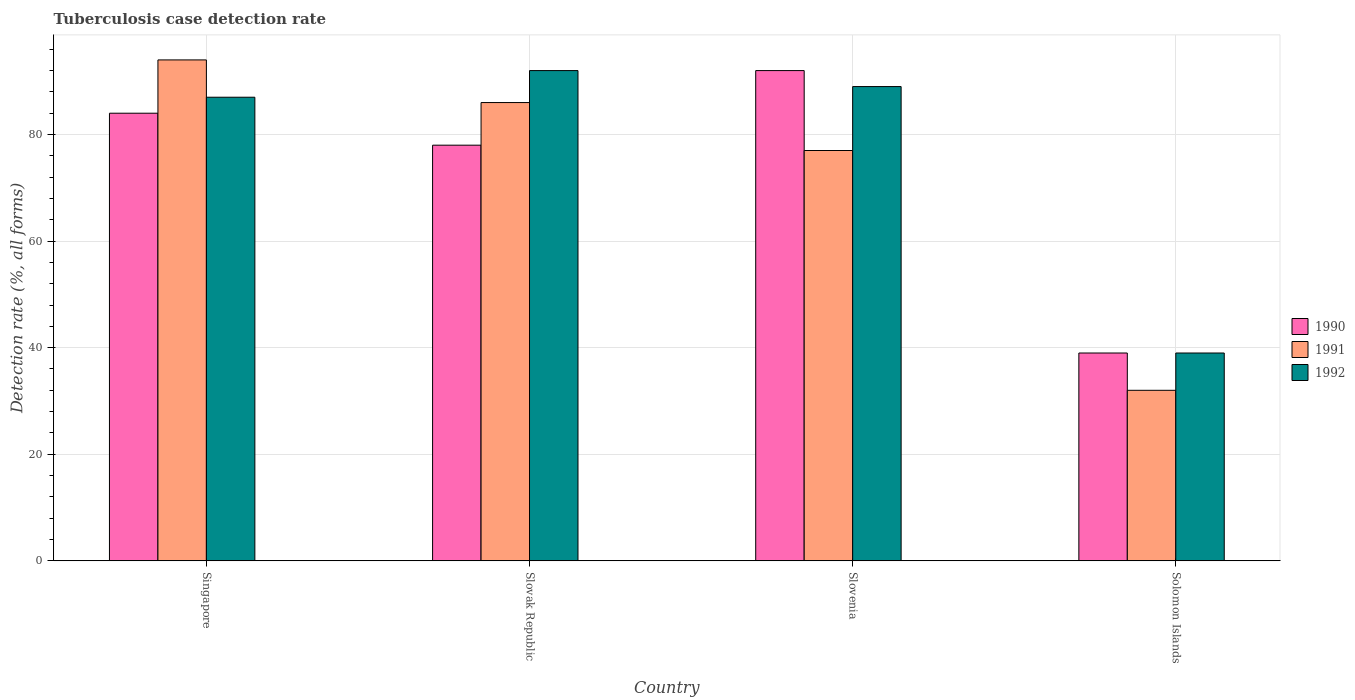How many different coloured bars are there?
Provide a succinct answer. 3. How many bars are there on the 1st tick from the left?
Your response must be concise. 3. What is the label of the 2nd group of bars from the left?
Provide a succinct answer. Slovak Republic. In how many cases, is the number of bars for a given country not equal to the number of legend labels?
Ensure brevity in your answer.  0. What is the tuberculosis case detection rate in in 1990 in Solomon Islands?
Your response must be concise. 39. Across all countries, what is the maximum tuberculosis case detection rate in in 1992?
Provide a succinct answer. 92. In which country was the tuberculosis case detection rate in in 1991 maximum?
Offer a very short reply. Singapore. In which country was the tuberculosis case detection rate in in 1991 minimum?
Your response must be concise. Solomon Islands. What is the total tuberculosis case detection rate in in 1992 in the graph?
Provide a short and direct response. 307. What is the difference between the tuberculosis case detection rate in in 1991 in Singapore and that in Slovenia?
Ensure brevity in your answer.  17. What is the difference between the tuberculosis case detection rate in in 1992 in Solomon Islands and the tuberculosis case detection rate in in 1990 in Singapore?
Your answer should be very brief. -45. What is the average tuberculosis case detection rate in in 1992 per country?
Ensure brevity in your answer.  76.75. In how many countries, is the tuberculosis case detection rate in in 1992 greater than 24 %?
Offer a very short reply. 4. What is the ratio of the tuberculosis case detection rate in in 1990 in Slovenia to that in Solomon Islands?
Provide a succinct answer. 2.36. Is the difference between the tuberculosis case detection rate in in 1990 in Singapore and Solomon Islands greater than the difference between the tuberculosis case detection rate in in 1991 in Singapore and Solomon Islands?
Offer a very short reply. No. What is the difference between the highest and the lowest tuberculosis case detection rate in in 1990?
Provide a succinct answer. 53. What does the 2nd bar from the right in Solomon Islands represents?
Keep it short and to the point. 1991. What is the difference between two consecutive major ticks on the Y-axis?
Make the answer very short. 20. Does the graph contain any zero values?
Keep it short and to the point. No. Does the graph contain grids?
Offer a terse response. Yes. What is the title of the graph?
Your answer should be very brief. Tuberculosis case detection rate. What is the label or title of the Y-axis?
Offer a terse response. Detection rate (%, all forms). What is the Detection rate (%, all forms) of 1990 in Singapore?
Your answer should be very brief. 84. What is the Detection rate (%, all forms) in 1991 in Singapore?
Make the answer very short. 94. What is the Detection rate (%, all forms) of 1990 in Slovak Republic?
Keep it short and to the point. 78. What is the Detection rate (%, all forms) in 1991 in Slovak Republic?
Provide a succinct answer. 86. What is the Detection rate (%, all forms) of 1992 in Slovak Republic?
Your answer should be compact. 92. What is the Detection rate (%, all forms) of 1990 in Slovenia?
Your answer should be compact. 92. What is the Detection rate (%, all forms) in 1992 in Slovenia?
Provide a short and direct response. 89. What is the Detection rate (%, all forms) of 1991 in Solomon Islands?
Make the answer very short. 32. What is the Detection rate (%, all forms) in 1992 in Solomon Islands?
Keep it short and to the point. 39. Across all countries, what is the maximum Detection rate (%, all forms) in 1990?
Ensure brevity in your answer.  92. Across all countries, what is the maximum Detection rate (%, all forms) in 1991?
Provide a succinct answer. 94. Across all countries, what is the maximum Detection rate (%, all forms) in 1992?
Your answer should be compact. 92. Across all countries, what is the minimum Detection rate (%, all forms) in 1990?
Ensure brevity in your answer.  39. Across all countries, what is the minimum Detection rate (%, all forms) in 1991?
Ensure brevity in your answer.  32. What is the total Detection rate (%, all forms) of 1990 in the graph?
Make the answer very short. 293. What is the total Detection rate (%, all forms) in 1991 in the graph?
Give a very brief answer. 289. What is the total Detection rate (%, all forms) in 1992 in the graph?
Provide a short and direct response. 307. What is the difference between the Detection rate (%, all forms) in 1990 in Singapore and that in Slovak Republic?
Provide a succinct answer. 6. What is the difference between the Detection rate (%, all forms) in 1991 in Singapore and that in Slovak Republic?
Ensure brevity in your answer.  8. What is the difference between the Detection rate (%, all forms) of 1990 in Singapore and that in Slovenia?
Offer a terse response. -8. What is the difference between the Detection rate (%, all forms) in 1991 in Singapore and that in Slovenia?
Your response must be concise. 17. What is the difference between the Detection rate (%, all forms) in 1992 in Singapore and that in Slovenia?
Give a very brief answer. -2. What is the difference between the Detection rate (%, all forms) of 1990 in Singapore and that in Solomon Islands?
Your response must be concise. 45. What is the difference between the Detection rate (%, all forms) in 1992 in Singapore and that in Solomon Islands?
Ensure brevity in your answer.  48. What is the difference between the Detection rate (%, all forms) of 1990 in Slovak Republic and that in Slovenia?
Offer a very short reply. -14. What is the difference between the Detection rate (%, all forms) of 1992 in Slovak Republic and that in Slovenia?
Your answer should be very brief. 3. What is the difference between the Detection rate (%, all forms) of 1991 in Slovak Republic and that in Solomon Islands?
Offer a very short reply. 54. What is the difference between the Detection rate (%, all forms) in 1992 in Slovak Republic and that in Solomon Islands?
Your response must be concise. 53. What is the difference between the Detection rate (%, all forms) of 1990 in Slovenia and that in Solomon Islands?
Offer a terse response. 53. What is the difference between the Detection rate (%, all forms) of 1991 in Slovenia and that in Solomon Islands?
Your answer should be very brief. 45. What is the difference between the Detection rate (%, all forms) in 1990 in Singapore and the Detection rate (%, all forms) in 1991 in Slovak Republic?
Provide a succinct answer. -2. What is the difference between the Detection rate (%, all forms) in 1990 in Singapore and the Detection rate (%, all forms) in 1992 in Slovak Republic?
Your answer should be compact. -8. What is the difference between the Detection rate (%, all forms) in 1990 in Singapore and the Detection rate (%, all forms) in 1992 in Slovenia?
Provide a short and direct response. -5. What is the difference between the Detection rate (%, all forms) of 1991 in Singapore and the Detection rate (%, all forms) of 1992 in Slovenia?
Your answer should be very brief. 5. What is the difference between the Detection rate (%, all forms) in 1990 in Singapore and the Detection rate (%, all forms) in 1991 in Solomon Islands?
Your answer should be very brief. 52. What is the difference between the Detection rate (%, all forms) of 1990 in Singapore and the Detection rate (%, all forms) of 1992 in Solomon Islands?
Make the answer very short. 45. What is the difference between the Detection rate (%, all forms) of 1990 in Slovak Republic and the Detection rate (%, all forms) of 1991 in Slovenia?
Offer a terse response. 1. What is the difference between the Detection rate (%, all forms) in 1990 in Slovak Republic and the Detection rate (%, all forms) in 1992 in Slovenia?
Offer a very short reply. -11. What is the difference between the Detection rate (%, all forms) of 1991 in Slovak Republic and the Detection rate (%, all forms) of 1992 in Slovenia?
Provide a short and direct response. -3. What is the difference between the Detection rate (%, all forms) in 1990 in Slovak Republic and the Detection rate (%, all forms) in 1992 in Solomon Islands?
Your response must be concise. 39. What is the difference between the Detection rate (%, all forms) of 1991 in Slovak Republic and the Detection rate (%, all forms) of 1992 in Solomon Islands?
Provide a succinct answer. 47. What is the difference between the Detection rate (%, all forms) in 1991 in Slovenia and the Detection rate (%, all forms) in 1992 in Solomon Islands?
Provide a succinct answer. 38. What is the average Detection rate (%, all forms) in 1990 per country?
Your answer should be very brief. 73.25. What is the average Detection rate (%, all forms) of 1991 per country?
Provide a short and direct response. 72.25. What is the average Detection rate (%, all forms) in 1992 per country?
Provide a succinct answer. 76.75. What is the difference between the Detection rate (%, all forms) in 1990 and Detection rate (%, all forms) in 1991 in Singapore?
Offer a very short reply. -10. What is the difference between the Detection rate (%, all forms) in 1991 and Detection rate (%, all forms) in 1992 in Singapore?
Your response must be concise. 7. What is the difference between the Detection rate (%, all forms) of 1990 and Detection rate (%, all forms) of 1991 in Slovak Republic?
Provide a short and direct response. -8. What is the difference between the Detection rate (%, all forms) of 1991 and Detection rate (%, all forms) of 1992 in Slovak Republic?
Give a very brief answer. -6. What is the difference between the Detection rate (%, all forms) in 1990 and Detection rate (%, all forms) in 1991 in Solomon Islands?
Give a very brief answer. 7. What is the ratio of the Detection rate (%, all forms) in 1991 in Singapore to that in Slovak Republic?
Your answer should be compact. 1.09. What is the ratio of the Detection rate (%, all forms) in 1992 in Singapore to that in Slovak Republic?
Your answer should be compact. 0.95. What is the ratio of the Detection rate (%, all forms) of 1991 in Singapore to that in Slovenia?
Your answer should be compact. 1.22. What is the ratio of the Detection rate (%, all forms) of 1992 in Singapore to that in Slovenia?
Your response must be concise. 0.98. What is the ratio of the Detection rate (%, all forms) in 1990 in Singapore to that in Solomon Islands?
Give a very brief answer. 2.15. What is the ratio of the Detection rate (%, all forms) in 1991 in Singapore to that in Solomon Islands?
Offer a terse response. 2.94. What is the ratio of the Detection rate (%, all forms) of 1992 in Singapore to that in Solomon Islands?
Offer a very short reply. 2.23. What is the ratio of the Detection rate (%, all forms) of 1990 in Slovak Republic to that in Slovenia?
Give a very brief answer. 0.85. What is the ratio of the Detection rate (%, all forms) of 1991 in Slovak Republic to that in Slovenia?
Keep it short and to the point. 1.12. What is the ratio of the Detection rate (%, all forms) of 1992 in Slovak Republic to that in Slovenia?
Ensure brevity in your answer.  1.03. What is the ratio of the Detection rate (%, all forms) in 1990 in Slovak Republic to that in Solomon Islands?
Offer a very short reply. 2. What is the ratio of the Detection rate (%, all forms) of 1991 in Slovak Republic to that in Solomon Islands?
Your answer should be compact. 2.69. What is the ratio of the Detection rate (%, all forms) in 1992 in Slovak Republic to that in Solomon Islands?
Your answer should be compact. 2.36. What is the ratio of the Detection rate (%, all forms) of 1990 in Slovenia to that in Solomon Islands?
Your answer should be compact. 2.36. What is the ratio of the Detection rate (%, all forms) of 1991 in Slovenia to that in Solomon Islands?
Keep it short and to the point. 2.41. What is the ratio of the Detection rate (%, all forms) in 1992 in Slovenia to that in Solomon Islands?
Offer a terse response. 2.28. What is the difference between the highest and the second highest Detection rate (%, all forms) of 1990?
Your answer should be compact. 8. What is the difference between the highest and the second highest Detection rate (%, all forms) of 1992?
Make the answer very short. 3. What is the difference between the highest and the lowest Detection rate (%, all forms) of 1990?
Ensure brevity in your answer.  53. What is the difference between the highest and the lowest Detection rate (%, all forms) in 1991?
Provide a succinct answer. 62. 